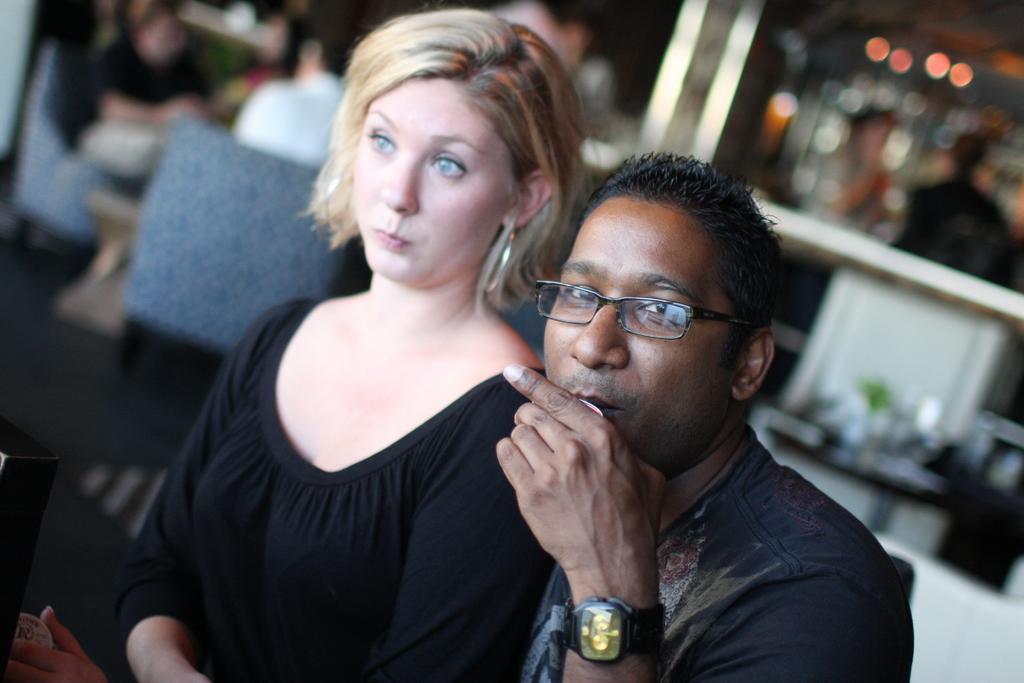Please provide a concise description of this image. In this picture there are two people, among them there's a man holding a cup. In the background of the image it is blurry and we can see chairs and people. 